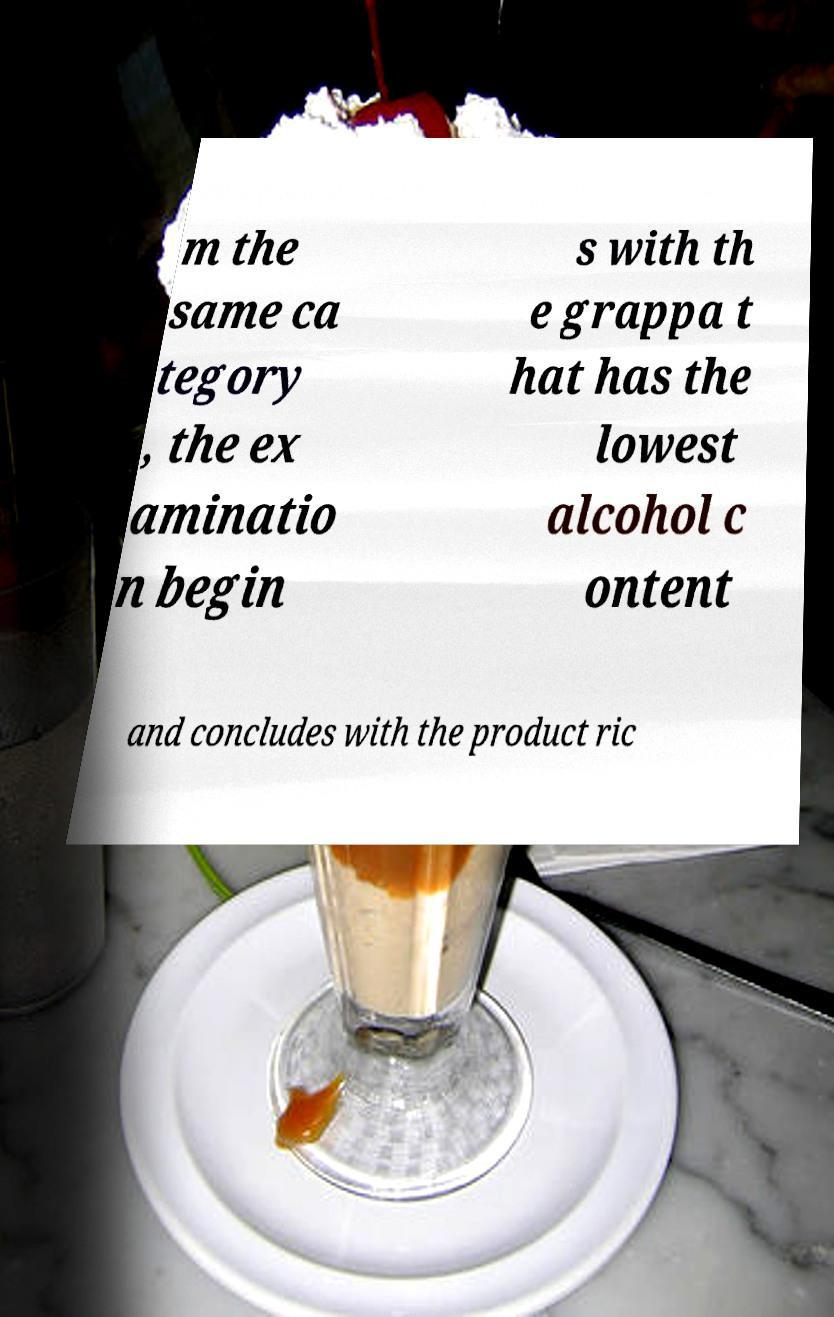For documentation purposes, I need the text within this image transcribed. Could you provide that? m the same ca tegory , the ex aminatio n begin s with th e grappa t hat has the lowest alcohol c ontent and concludes with the product ric 